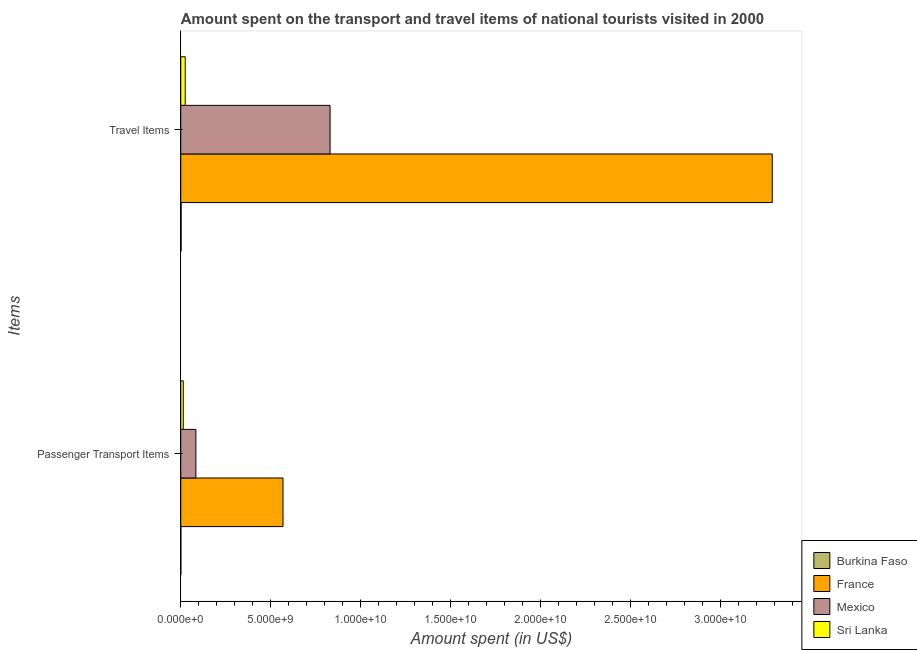How many different coloured bars are there?
Keep it short and to the point. 4. How many bars are there on the 1st tick from the bottom?
Make the answer very short. 4. What is the label of the 1st group of bars from the top?
Offer a terse response. Travel Items. What is the amount spent on passenger transport items in France?
Provide a short and direct response. 5.68e+09. Across all countries, what is the maximum amount spent on passenger transport items?
Your answer should be very brief. 5.68e+09. Across all countries, what is the minimum amount spent in travel items?
Provide a short and direct response. 1.90e+07. In which country was the amount spent in travel items maximum?
Provide a succinct answer. France. In which country was the amount spent in travel items minimum?
Keep it short and to the point. Burkina Faso. What is the total amount spent on passenger transport items in the graph?
Provide a succinct answer. 6.66e+09. What is the difference between the amount spent in travel items in Sri Lanka and that in Burkina Faso?
Provide a short and direct response. 2.29e+08. What is the difference between the amount spent on passenger transport items in France and the amount spent in travel items in Burkina Faso?
Offer a very short reply. 5.66e+09. What is the average amount spent in travel items per country?
Your response must be concise. 1.04e+1. What is the difference between the amount spent in travel items and amount spent on passenger transport items in France?
Your response must be concise. 2.72e+1. What is the ratio of the amount spent on passenger transport items in Sri Lanka to that in Mexico?
Offer a very short reply. 0.17. What does the 2nd bar from the top in Travel Items represents?
Your response must be concise. Mexico. What is the difference between two consecutive major ticks on the X-axis?
Your answer should be compact. 5.00e+09. Does the graph contain any zero values?
Ensure brevity in your answer.  No. Does the graph contain grids?
Offer a terse response. No. Where does the legend appear in the graph?
Your answer should be very brief. Bottom right. How are the legend labels stacked?
Your answer should be compact. Vertical. What is the title of the graph?
Your answer should be very brief. Amount spent on the transport and travel items of national tourists visited in 2000. Does "China" appear as one of the legend labels in the graph?
Offer a very short reply. No. What is the label or title of the X-axis?
Ensure brevity in your answer.  Amount spent (in US$). What is the label or title of the Y-axis?
Offer a very short reply. Items. What is the Amount spent (in US$) of Burkina Faso in Passenger Transport Items?
Ensure brevity in your answer.  4.00e+06. What is the Amount spent (in US$) in France in Passenger Transport Items?
Your answer should be compact. 5.68e+09. What is the Amount spent (in US$) of Mexico in Passenger Transport Items?
Your response must be concise. 8.39e+08. What is the Amount spent (in US$) of Sri Lanka in Passenger Transport Items?
Give a very brief answer. 1.40e+08. What is the Amount spent (in US$) in Burkina Faso in Travel Items?
Your answer should be compact. 1.90e+07. What is the Amount spent (in US$) of France in Travel Items?
Give a very brief answer. 3.29e+1. What is the Amount spent (in US$) of Mexico in Travel Items?
Offer a terse response. 8.29e+09. What is the Amount spent (in US$) of Sri Lanka in Travel Items?
Provide a succinct answer. 2.48e+08. Across all Items, what is the maximum Amount spent (in US$) of Burkina Faso?
Offer a terse response. 1.90e+07. Across all Items, what is the maximum Amount spent (in US$) of France?
Keep it short and to the point. 3.29e+1. Across all Items, what is the maximum Amount spent (in US$) in Mexico?
Your answer should be compact. 8.29e+09. Across all Items, what is the maximum Amount spent (in US$) of Sri Lanka?
Your response must be concise. 2.48e+08. Across all Items, what is the minimum Amount spent (in US$) of France?
Offer a terse response. 5.68e+09. Across all Items, what is the minimum Amount spent (in US$) of Mexico?
Provide a succinct answer. 8.39e+08. Across all Items, what is the minimum Amount spent (in US$) in Sri Lanka?
Provide a succinct answer. 1.40e+08. What is the total Amount spent (in US$) of Burkina Faso in the graph?
Provide a short and direct response. 2.30e+07. What is the total Amount spent (in US$) in France in the graph?
Your response must be concise. 3.85e+1. What is the total Amount spent (in US$) of Mexico in the graph?
Provide a short and direct response. 9.13e+09. What is the total Amount spent (in US$) of Sri Lanka in the graph?
Give a very brief answer. 3.88e+08. What is the difference between the Amount spent (in US$) of Burkina Faso in Passenger Transport Items and that in Travel Items?
Provide a short and direct response. -1.50e+07. What is the difference between the Amount spent (in US$) in France in Passenger Transport Items and that in Travel Items?
Ensure brevity in your answer.  -2.72e+1. What is the difference between the Amount spent (in US$) in Mexico in Passenger Transport Items and that in Travel Items?
Provide a short and direct response. -7.46e+09. What is the difference between the Amount spent (in US$) of Sri Lanka in Passenger Transport Items and that in Travel Items?
Give a very brief answer. -1.08e+08. What is the difference between the Amount spent (in US$) of Burkina Faso in Passenger Transport Items and the Amount spent (in US$) of France in Travel Items?
Offer a very short reply. -3.29e+1. What is the difference between the Amount spent (in US$) of Burkina Faso in Passenger Transport Items and the Amount spent (in US$) of Mexico in Travel Items?
Keep it short and to the point. -8.29e+09. What is the difference between the Amount spent (in US$) in Burkina Faso in Passenger Transport Items and the Amount spent (in US$) in Sri Lanka in Travel Items?
Offer a terse response. -2.44e+08. What is the difference between the Amount spent (in US$) of France in Passenger Transport Items and the Amount spent (in US$) of Mexico in Travel Items?
Offer a very short reply. -2.62e+09. What is the difference between the Amount spent (in US$) in France in Passenger Transport Items and the Amount spent (in US$) in Sri Lanka in Travel Items?
Provide a succinct answer. 5.43e+09. What is the difference between the Amount spent (in US$) in Mexico in Passenger Transport Items and the Amount spent (in US$) in Sri Lanka in Travel Items?
Keep it short and to the point. 5.91e+08. What is the average Amount spent (in US$) of Burkina Faso per Items?
Your response must be concise. 1.15e+07. What is the average Amount spent (in US$) of France per Items?
Provide a short and direct response. 1.93e+1. What is the average Amount spent (in US$) of Mexico per Items?
Make the answer very short. 4.57e+09. What is the average Amount spent (in US$) of Sri Lanka per Items?
Your response must be concise. 1.94e+08. What is the difference between the Amount spent (in US$) in Burkina Faso and Amount spent (in US$) in France in Passenger Transport Items?
Your answer should be compact. -5.68e+09. What is the difference between the Amount spent (in US$) in Burkina Faso and Amount spent (in US$) in Mexico in Passenger Transport Items?
Provide a short and direct response. -8.35e+08. What is the difference between the Amount spent (in US$) in Burkina Faso and Amount spent (in US$) in Sri Lanka in Passenger Transport Items?
Give a very brief answer. -1.36e+08. What is the difference between the Amount spent (in US$) in France and Amount spent (in US$) in Mexico in Passenger Transport Items?
Give a very brief answer. 4.84e+09. What is the difference between the Amount spent (in US$) of France and Amount spent (in US$) of Sri Lanka in Passenger Transport Items?
Your answer should be compact. 5.54e+09. What is the difference between the Amount spent (in US$) in Mexico and Amount spent (in US$) in Sri Lanka in Passenger Transport Items?
Provide a short and direct response. 6.99e+08. What is the difference between the Amount spent (in US$) of Burkina Faso and Amount spent (in US$) of France in Travel Items?
Your response must be concise. -3.28e+1. What is the difference between the Amount spent (in US$) of Burkina Faso and Amount spent (in US$) of Mexico in Travel Items?
Provide a short and direct response. -8.28e+09. What is the difference between the Amount spent (in US$) in Burkina Faso and Amount spent (in US$) in Sri Lanka in Travel Items?
Your answer should be very brief. -2.29e+08. What is the difference between the Amount spent (in US$) in France and Amount spent (in US$) in Mexico in Travel Items?
Provide a succinct answer. 2.46e+1. What is the difference between the Amount spent (in US$) of France and Amount spent (in US$) of Sri Lanka in Travel Items?
Provide a short and direct response. 3.26e+1. What is the difference between the Amount spent (in US$) in Mexico and Amount spent (in US$) in Sri Lanka in Travel Items?
Ensure brevity in your answer.  8.05e+09. What is the ratio of the Amount spent (in US$) in Burkina Faso in Passenger Transport Items to that in Travel Items?
Your answer should be compact. 0.21. What is the ratio of the Amount spent (in US$) in France in Passenger Transport Items to that in Travel Items?
Make the answer very short. 0.17. What is the ratio of the Amount spent (in US$) of Mexico in Passenger Transport Items to that in Travel Items?
Offer a very short reply. 0.1. What is the ratio of the Amount spent (in US$) of Sri Lanka in Passenger Transport Items to that in Travel Items?
Ensure brevity in your answer.  0.56. What is the difference between the highest and the second highest Amount spent (in US$) of Burkina Faso?
Keep it short and to the point. 1.50e+07. What is the difference between the highest and the second highest Amount spent (in US$) in France?
Your response must be concise. 2.72e+1. What is the difference between the highest and the second highest Amount spent (in US$) of Mexico?
Provide a short and direct response. 7.46e+09. What is the difference between the highest and the second highest Amount spent (in US$) of Sri Lanka?
Keep it short and to the point. 1.08e+08. What is the difference between the highest and the lowest Amount spent (in US$) of Burkina Faso?
Your answer should be very brief. 1.50e+07. What is the difference between the highest and the lowest Amount spent (in US$) in France?
Provide a succinct answer. 2.72e+1. What is the difference between the highest and the lowest Amount spent (in US$) of Mexico?
Your response must be concise. 7.46e+09. What is the difference between the highest and the lowest Amount spent (in US$) in Sri Lanka?
Provide a short and direct response. 1.08e+08. 